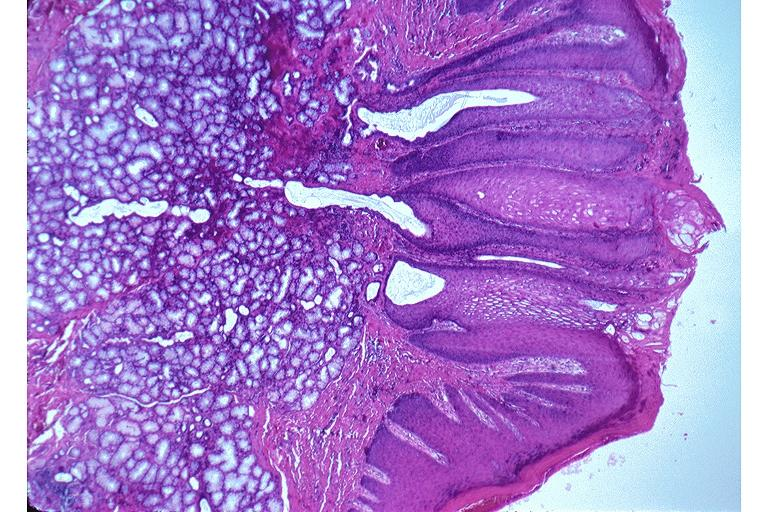s oral present?
Answer the question using a single word or phrase. Yes 